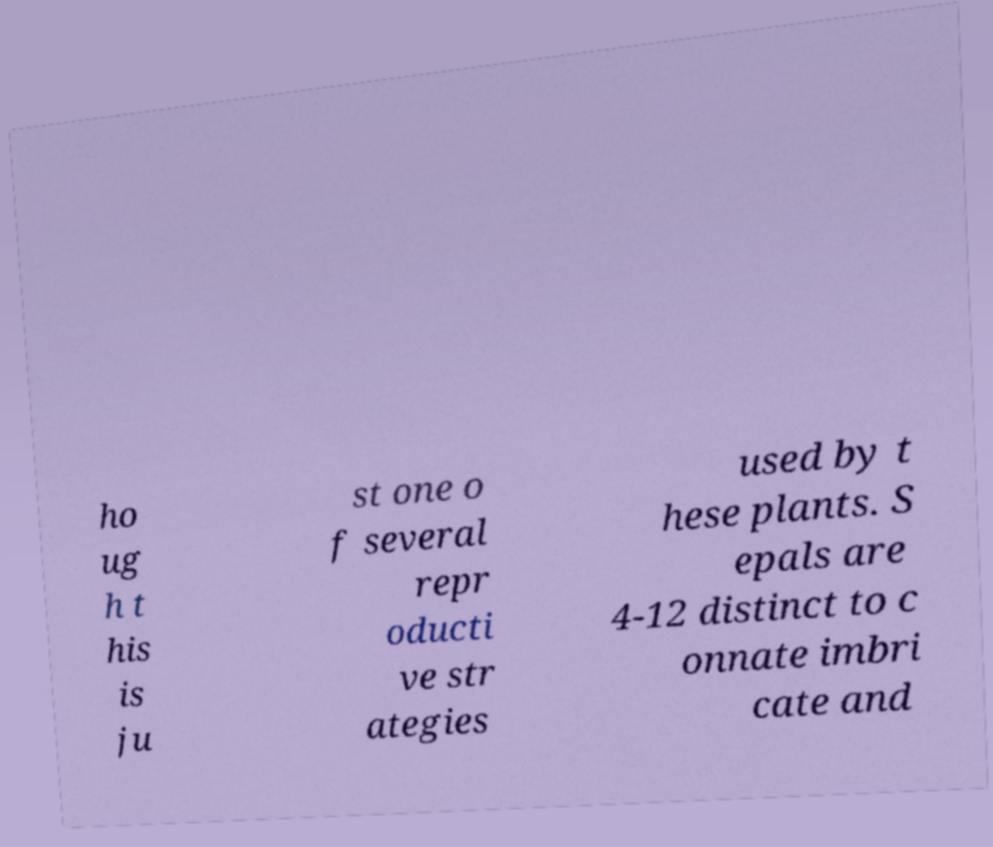What messages or text are displayed in this image? I need them in a readable, typed format. ho ug h t his is ju st one o f several repr oducti ve str ategies used by t hese plants. S epals are 4-12 distinct to c onnate imbri cate and 